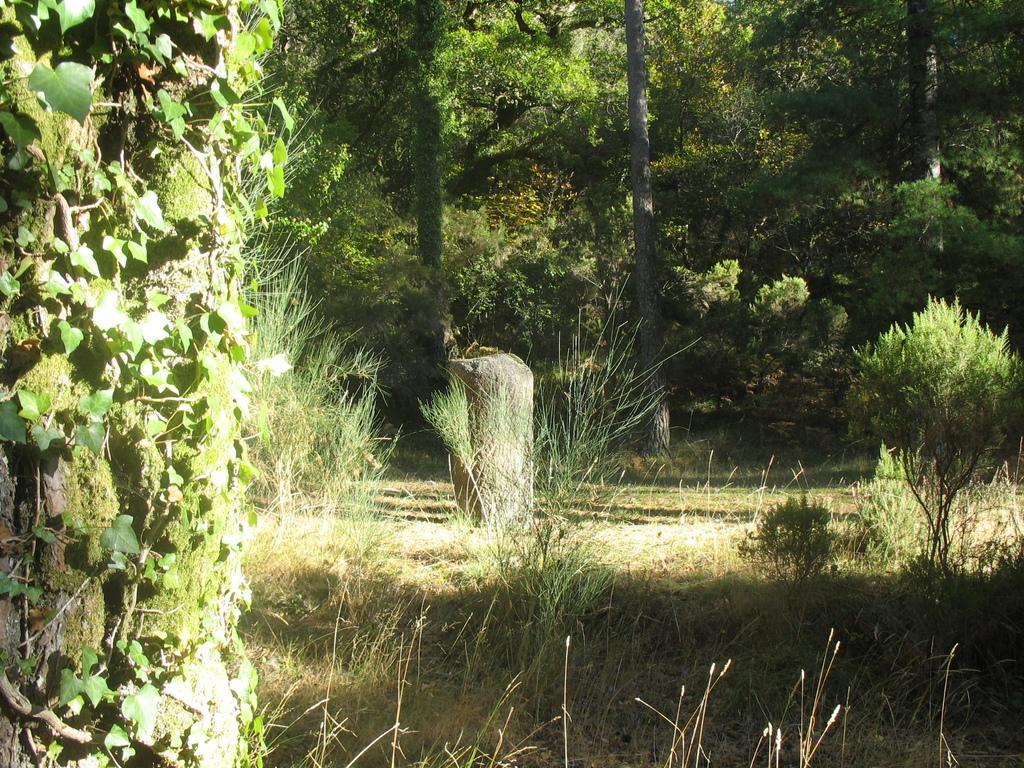Could you give a brief overview of what you see in this image? In this image we can see a stone, plants, creepers, grass and trees. 